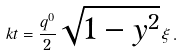Convert formula to latex. <formula><loc_0><loc_0><loc_500><loc_500>\ k t = \frac { q ^ { 0 } } { 2 } \sqrt { 1 - y ^ { 2 } } \, \xi \, .</formula> 